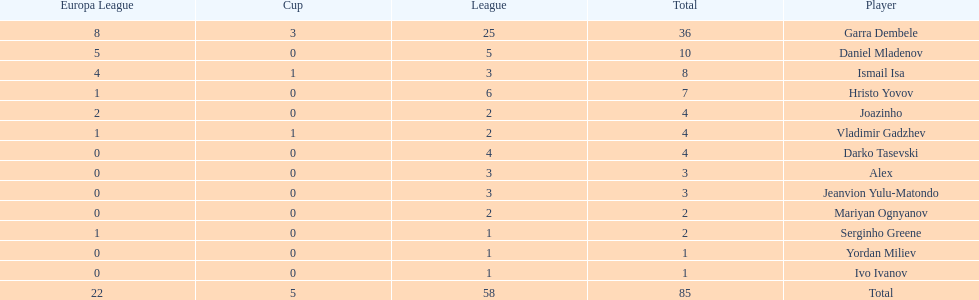Who had the most goal scores? Garra Dembele. 